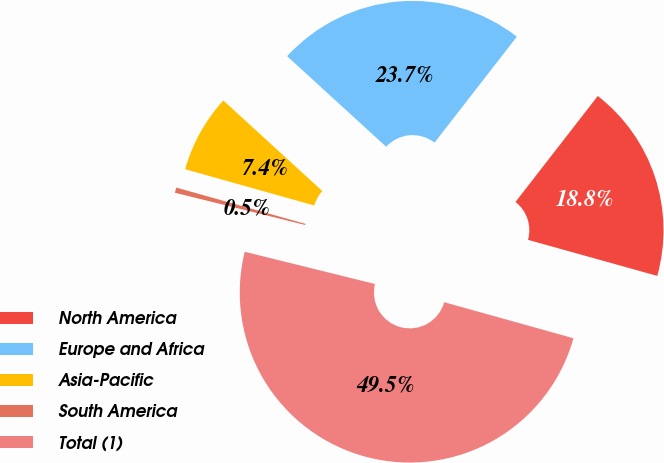Convert chart to OTSL. <chart><loc_0><loc_0><loc_500><loc_500><pie_chart><fcel>North America<fcel>Europe and Africa<fcel>Asia-Pacific<fcel>South America<fcel>Total (1)<nl><fcel>18.82%<fcel>23.72%<fcel>7.43%<fcel>0.5%<fcel>49.53%<nl></chart> 